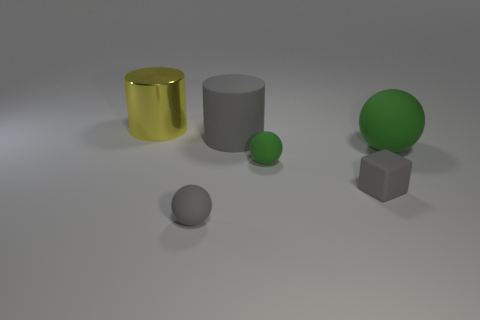There is another ball that is the same color as the big sphere; what is its size?
Your answer should be compact. Small. Are there more tiny gray blocks that are on the left side of the large yellow metal cylinder than big red cylinders?
Provide a short and direct response. No. Do the large yellow object and the green rubber thing right of the cube have the same shape?
Ensure brevity in your answer.  No. What number of other gray cylinders are the same size as the gray rubber cylinder?
Offer a terse response. 0. There is a green thing that is behind the green matte object that is to the left of the large green rubber object; what number of big cylinders are left of it?
Your response must be concise. 2. Are there an equal number of big green matte spheres left of the rubber cube and gray blocks behind the gray rubber cylinder?
Your answer should be very brief. Yes. What number of gray matte objects have the same shape as the small green object?
Provide a succinct answer. 1. Are there any small green spheres that have the same material as the big yellow cylinder?
Offer a terse response. No. There is a tiny matte thing that is the same color as the cube; what shape is it?
Make the answer very short. Sphere. How many yellow rubber cubes are there?
Your answer should be very brief. 0. 